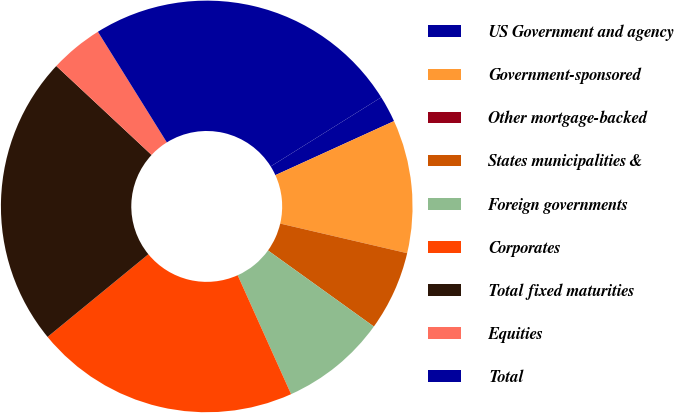Convert chart. <chart><loc_0><loc_0><loc_500><loc_500><pie_chart><fcel>US Government and agency<fcel>Government-sponsored<fcel>Other mortgage-backed<fcel>States municipalities &<fcel>Foreign governments<fcel>Corporates<fcel>Total fixed maturities<fcel>Equities<fcel>Total<nl><fcel>2.09%<fcel>10.45%<fcel>0.0%<fcel>6.27%<fcel>8.36%<fcel>20.79%<fcel>22.88%<fcel>4.18%<fcel>24.97%<nl></chart> 